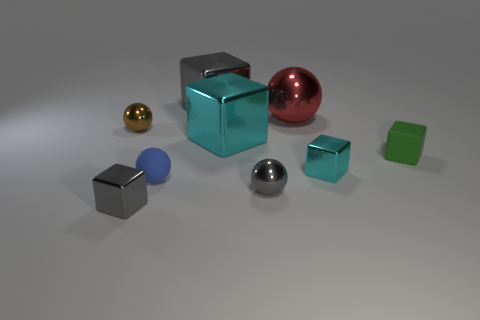Is the rubber sphere the same color as the large metal sphere? Upon observing the image, it appears that the rubber sphere, which has a matte texture and a deep golden hue, differs in color from the large metal sphere, which boasts a reflective surface with a rich reddish-copper tone. While both spheres exhibit warm colors, their shades are not identical. 